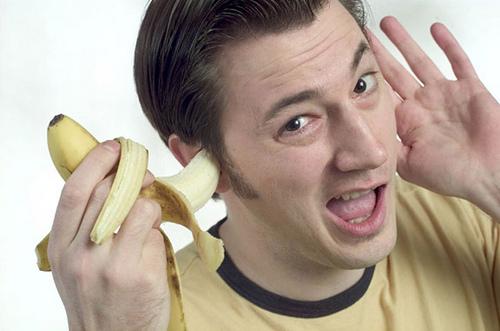Is this man trying to be funny?
Concise answer only. Yes. Does this man need professional help?
Answer briefly. No. Does the man need a shave?
Write a very short answer. No. Is this man using the telephone?
Answer briefly. No. 